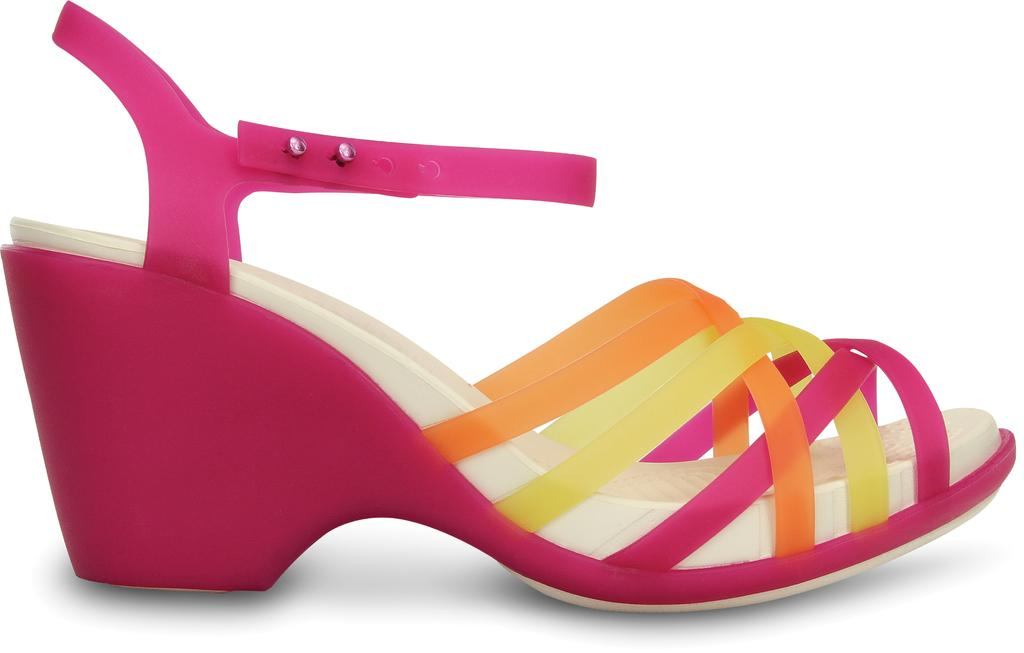What object is present in the image? There is a footwear in the image. Where is the footwear located? The footwear is on a surface. What color is the background of the image? The background of the image is white. What type of meat is being prepared in the image? There is no meat or any indication of food preparation in the image; it features a footwear on a surface. What news event is being discussed in the image? There is no discussion or any indication of a news event in the image; it features a footwear on a surface. 